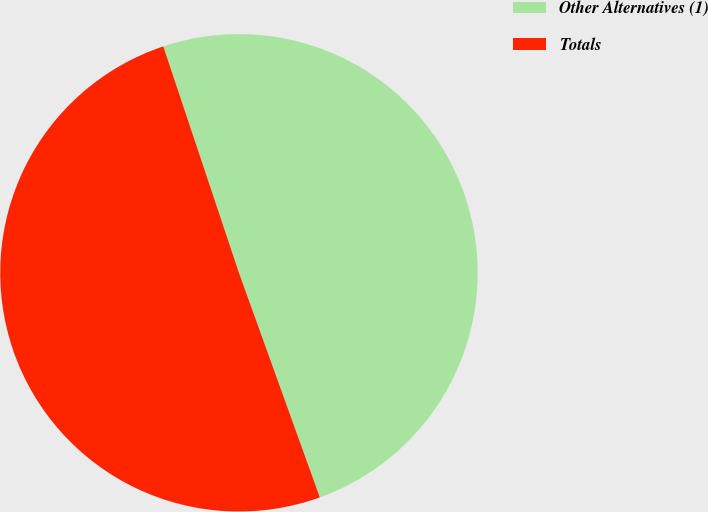Convert chart to OTSL. <chart><loc_0><loc_0><loc_500><loc_500><pie_chart><fcel>Other Alternatives (1)<fcel>Totals<nl><fcel>49.63%<fcel>50.37%<nl></chart> 